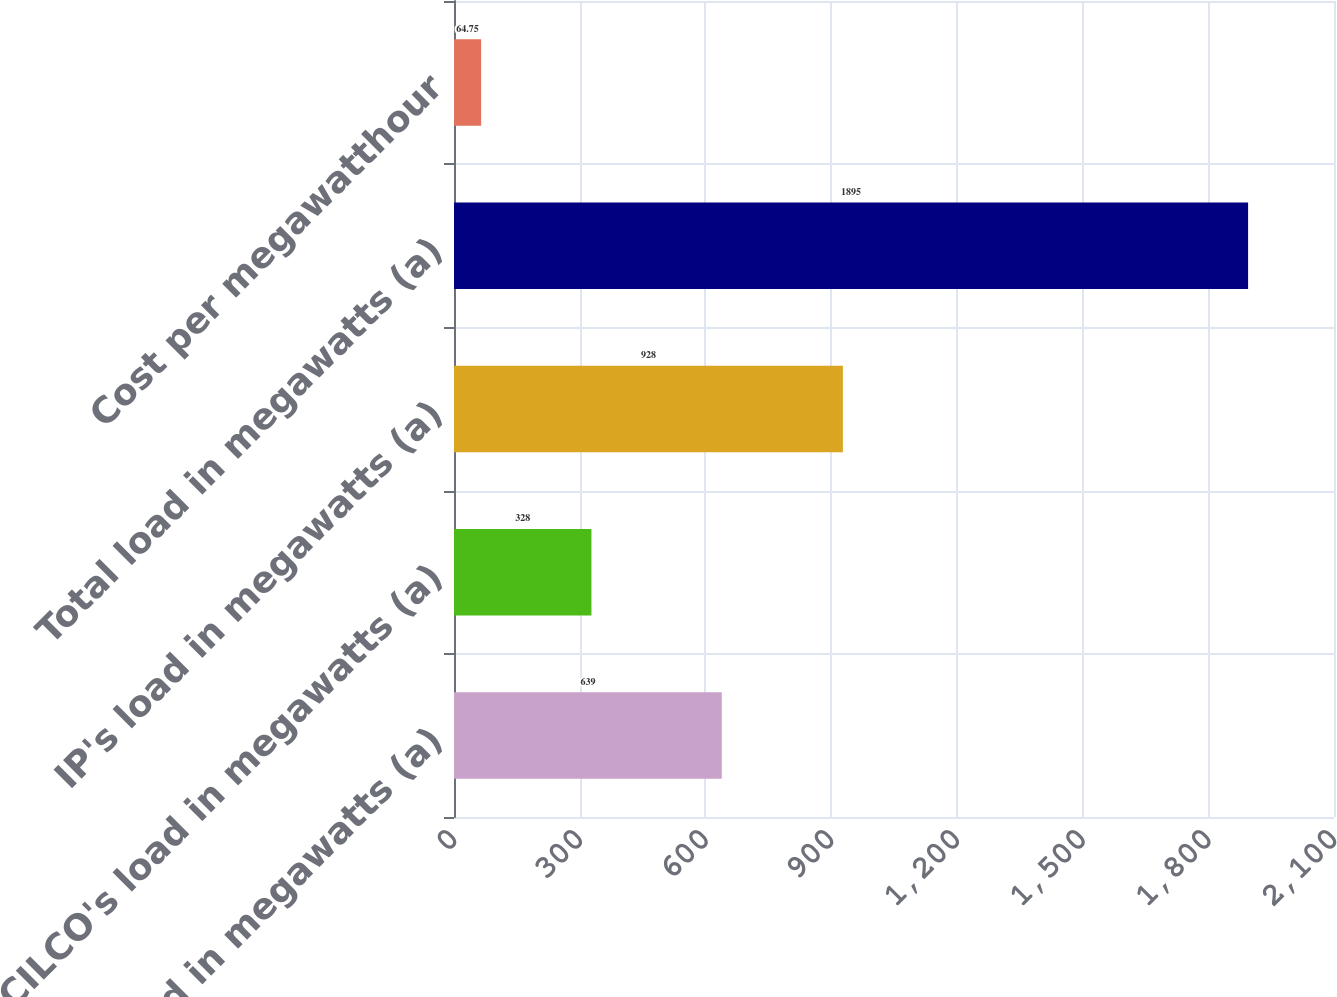<chart> <loc_0><loc_0><loc_500><loc_500><bar_chart><fcel>CIPS' load in megawatts (a)<fcel>CILCO's load in megawatts (a)<fcel>IP's load in megawatts (a)<fcel>Total load in megawatts (a)<fcel>Cost per megawatthour<nl><fcel>639<fcel>328<fcel>928<fcel>1895<fcel>64.75<nl></chart> 